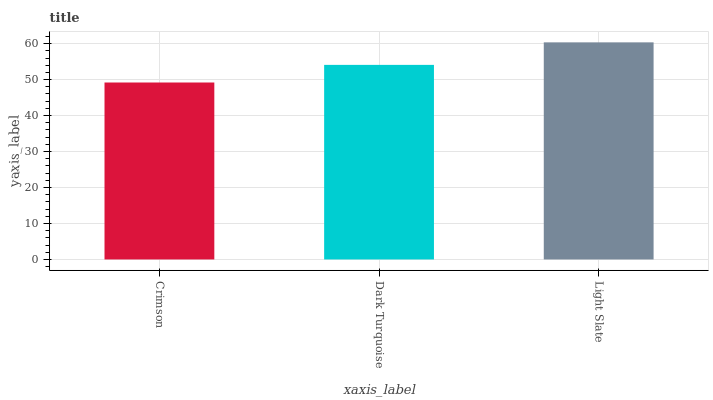Is Dark Turquoise the minimum?
Answer yes or no. No. Is Dark Turquoise the maximum?
Answer yes or no. No. Is Dark Turquoise greater than Crimson?
Answer yes or no. Yes. Is Crimson less than Dark Turquoise?
Answer yes or no. Yes. Is Crimson greater than Dark Turquoise?
Answer yes or no. No. Is Dark Turquoise less than Crimson?
Answer yes or no. No. Is Dark Turquoise the high median?
Answer yes or no. Yes. Is Dark Turquoise the low median?
Answer yes or no. Yes. Is Crimson the high median?
Answer yes or no. No. Is Light Slate the low median?
Answer yes or no. No. 